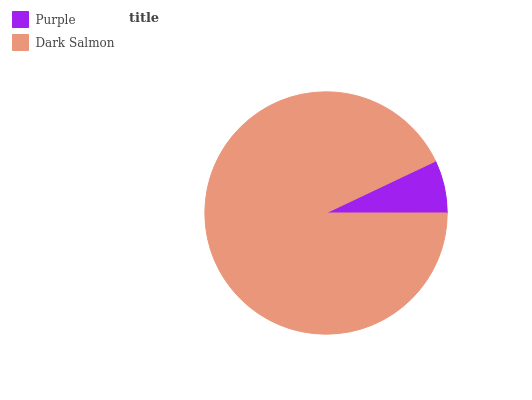Is Purple the minimum?
Answer yes or no. Yes. Is Dark Salmon the maximum?
Answer yes or no. Yes. Is Dark Salmon the minimum?
Answer yes or no. No. Is Dark Salmon greater than Purple?
Answer yes or no. Yes. Is Purple less than Dark Salmon?
Answer yes or no. Yes. Is Purple greater than Dark Salmon?
Answer yes or no. No. Is Dark Salmon less than Purple?
Answer yes or no. No. Is Dark Salmon the high median?
Answer yes or no. Yes. Is Purple the low median?
Answer yes or no. Yes. Is Purple the high median?
Answer yes or no. No. Is Dark Salmon the low median?
Answer yes or no. No. 